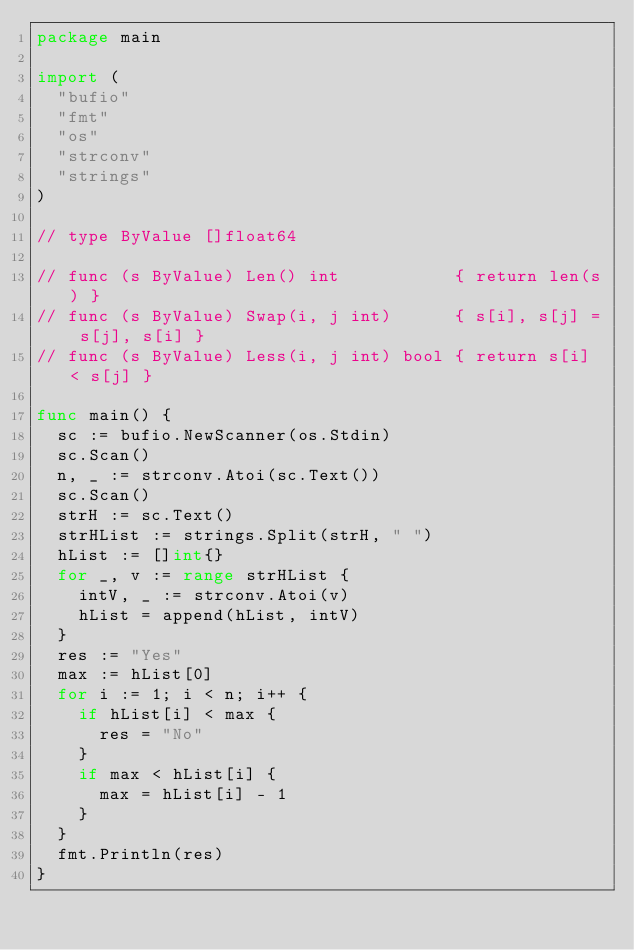Convert code to text. <code><loc_0><loc_0><loc_500><loc_500><_Go_>package main

import (
	"bufio"
	"fmt"
	"os"
	"strconv"
	"strings"
)

// type ByValue []float64

// func (s ByValue) Len() int           { return len(s) }
// func (s ByValue) Swap(i, j int)      { s[i], s[j] = s[j], s[i] }
// func (s ByValue) Less(i, j int) bool { return s[i] < s[j] }

func main() {
	sc := bufio.NewScanner(os.Stdin)
	sc.Scan()
	n, _ := strconv.Atoi(sc.Text())
	sc.Scan()
	strH := sc.Text()
	strHList := strings.Split(strH, " ")
	hList := []int{}
	for _, v := range strHList {
		intV, _ := strconv.Atoi(v)
		hList = append(hList, intV)
	}
	res := "Yes"
	max := hList[0]
	for i := 1; i < n; i++ {
		if hList[i] < max {
			res = "No"
		}
		if max < hList[i] {
			max = hList[i] - 1
		}
	}
	fmt.Println(res)
}
</code> 